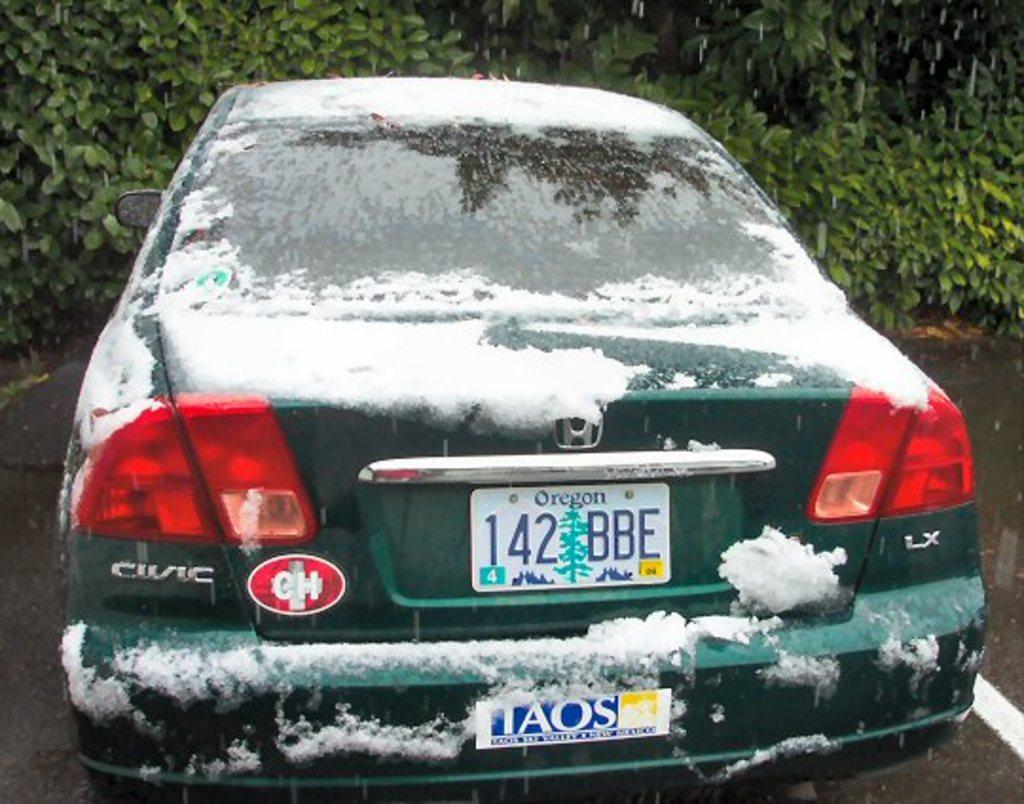<image>
Render a clear and concise summary of the photo. A Honda Civic has a license plate from Oregon on it. 